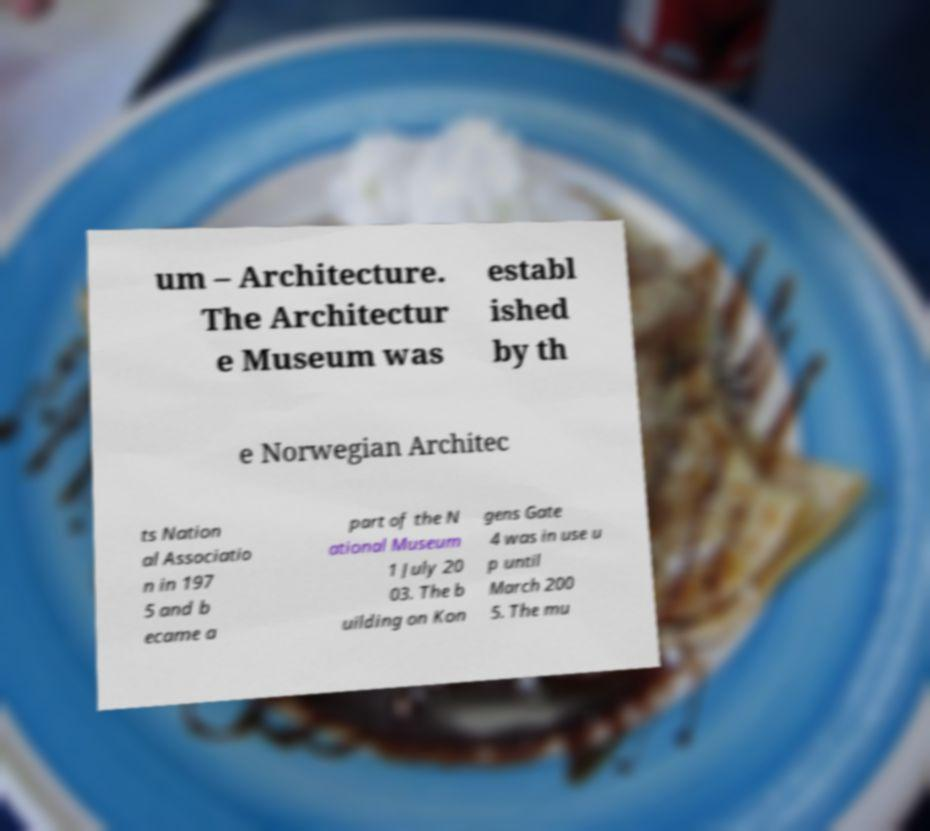I need the written content from this picture converted into text. Can you do that? um – Architecture. The Architectur e Museum was establ ished by th e Norwegian Architec ts Nation al Associatio n in 197 5 and b ecame a part of the N ational Museum 1 July 20 03. The b uilding on Kon gens Gate 4 was in use u p until March 200 5. The mu 